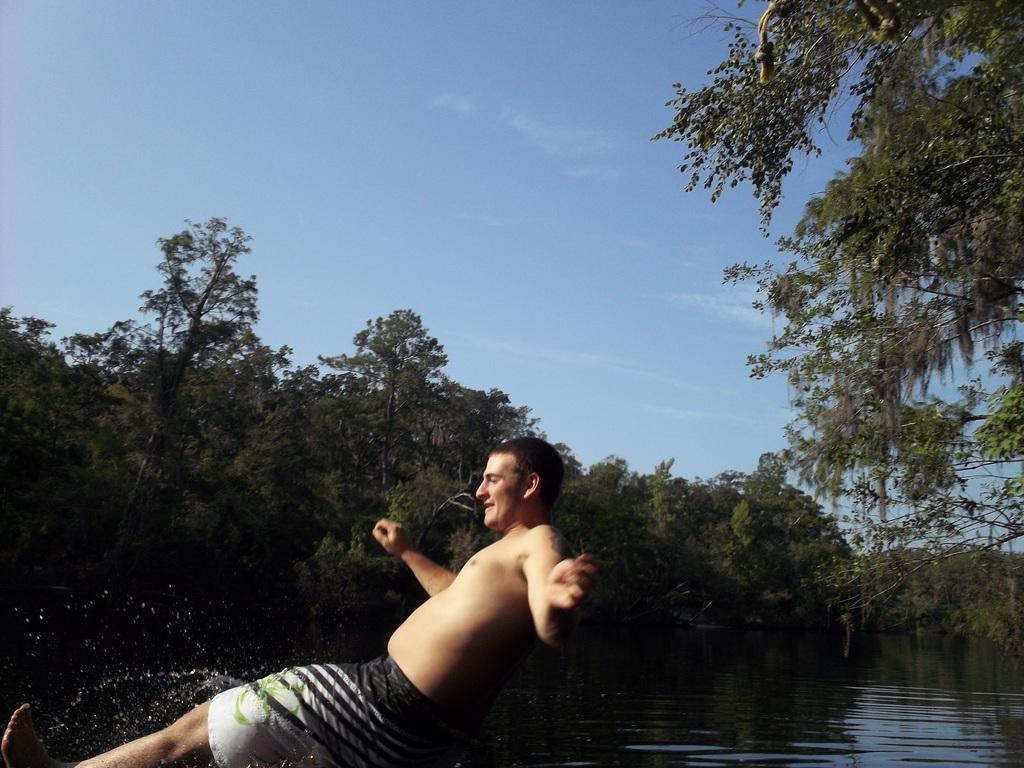Who is the person in the image? There is a man in the picture. What is the man wearing? The man is wearing shorts. What is the man doing in the image? The man is jumping into the river water. What can be seen in the background of the image? There are trees visible in the background of the image. Can you describe the tree in the right corner of the image? There is a tree in the right corner of the image. What type of quince is hanging from the tree in the image? There is no quince present in the image; it features a man jumping into a river with trees in the background. Is the man wearing a chain around his neck in the image? There is no mention of a chain in the provided facts, and it cannot be determined from the image. --- Facts: 1. There is a group of people in the image. 2. The people are sitting on a bench. 3. The bench is in a park. 4. There are trees in the background of the image. 5. The sky is visible in the image. Absurd Topics: elephant, parachute, volcano Conversation: Who is in the image? There is a group of people in the image. What are the people doing in the image? The people are sitting on a bench. Where is the bench located? The bench is in a park. What can be seen in the background of the image? There are trees in the background of the image. What is visible in the sky in the image? The sky is visible in the image. Reasoning: Let's think step by step in order to produce the conversation. We start by identifying the main subject in the image, which is the group of people. Then, we describe what the people are doing and where they are located. Next, we mention the background and the sky in the image. Each question is designed to elicit a specific detail about the image that is known from the provided facts. Absurd Question/Answer: Can you see an elephant parachuting from the volcano in the image? There is no elephant, parachute, or volcano present in the image. 